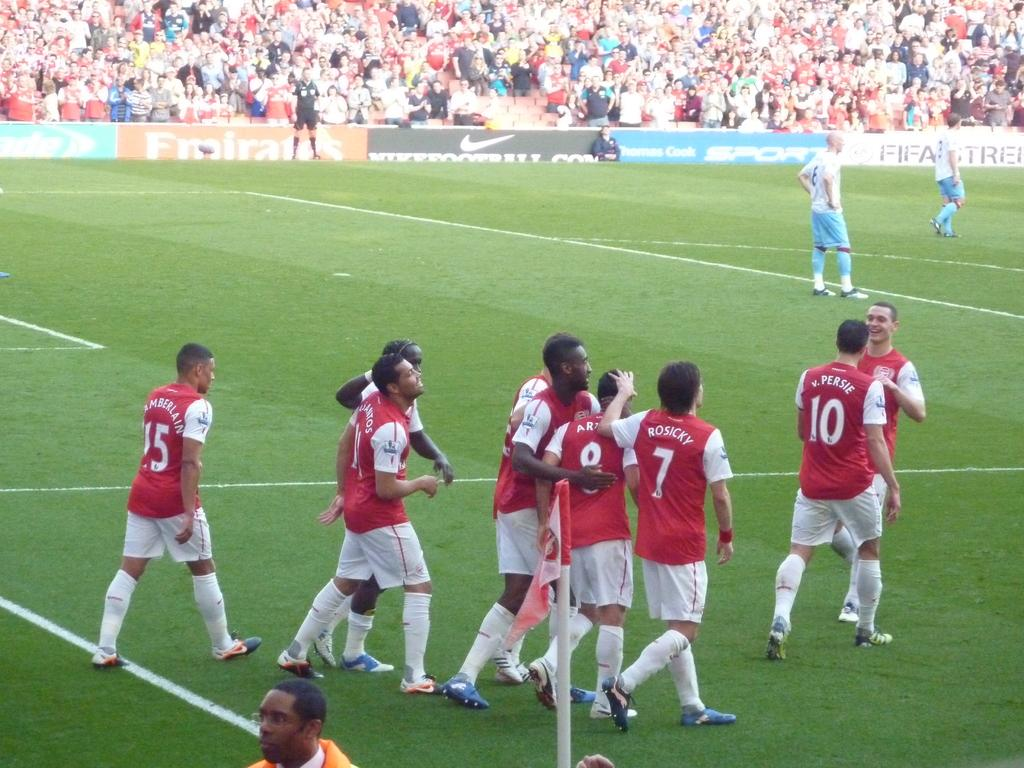<image>
Give a short and clear explanation of the subsequent image. Men are playing soccer on a field and one of them is named Rosicky. 